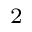<formula> <loc_0><loc_0><loc_500><loc_500>_ { 2 }</formula> 